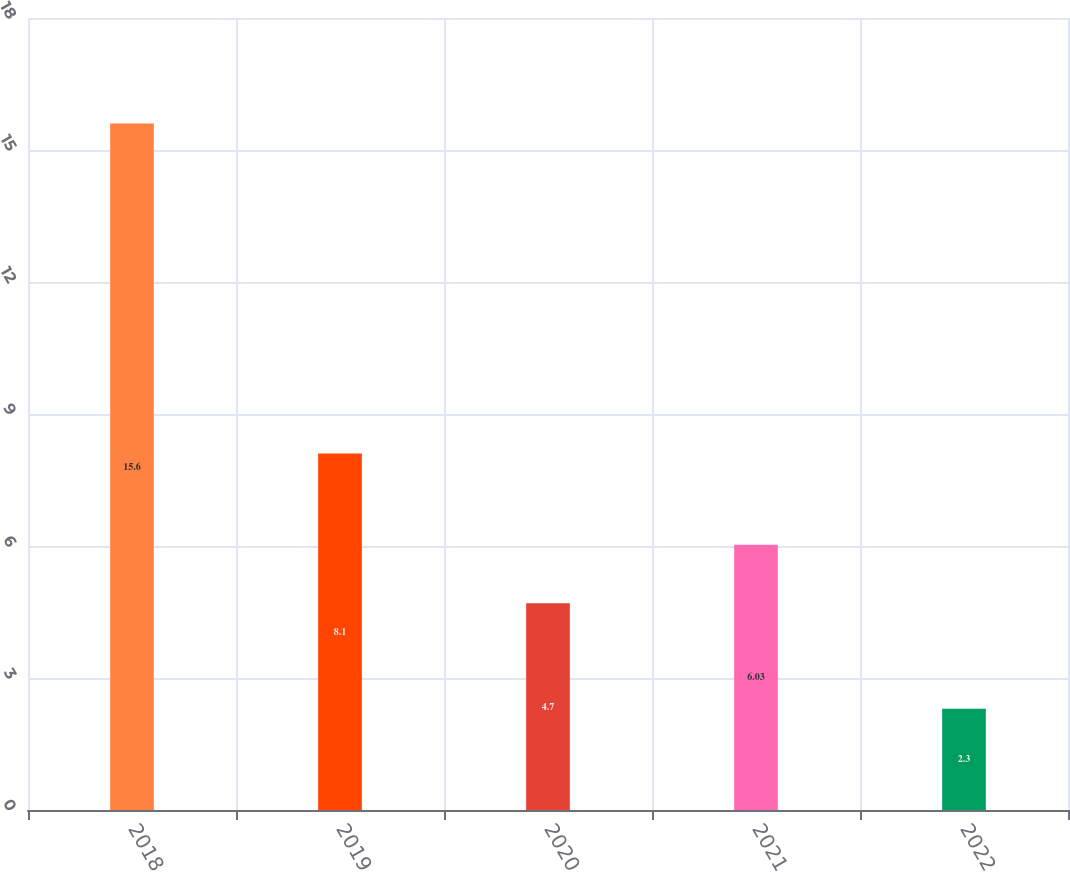Convert chart. <chart><loc_0><loc_0><loc_500><loc_500><bar_chart><fcel>2018<fcel>2019<fcel>2020<fcel>2021<fcel>2022<nl><fcel>15.6<fcel>8.1<fcel>4.7<fcel>6.03<fcel>2.3<nl></chart> 